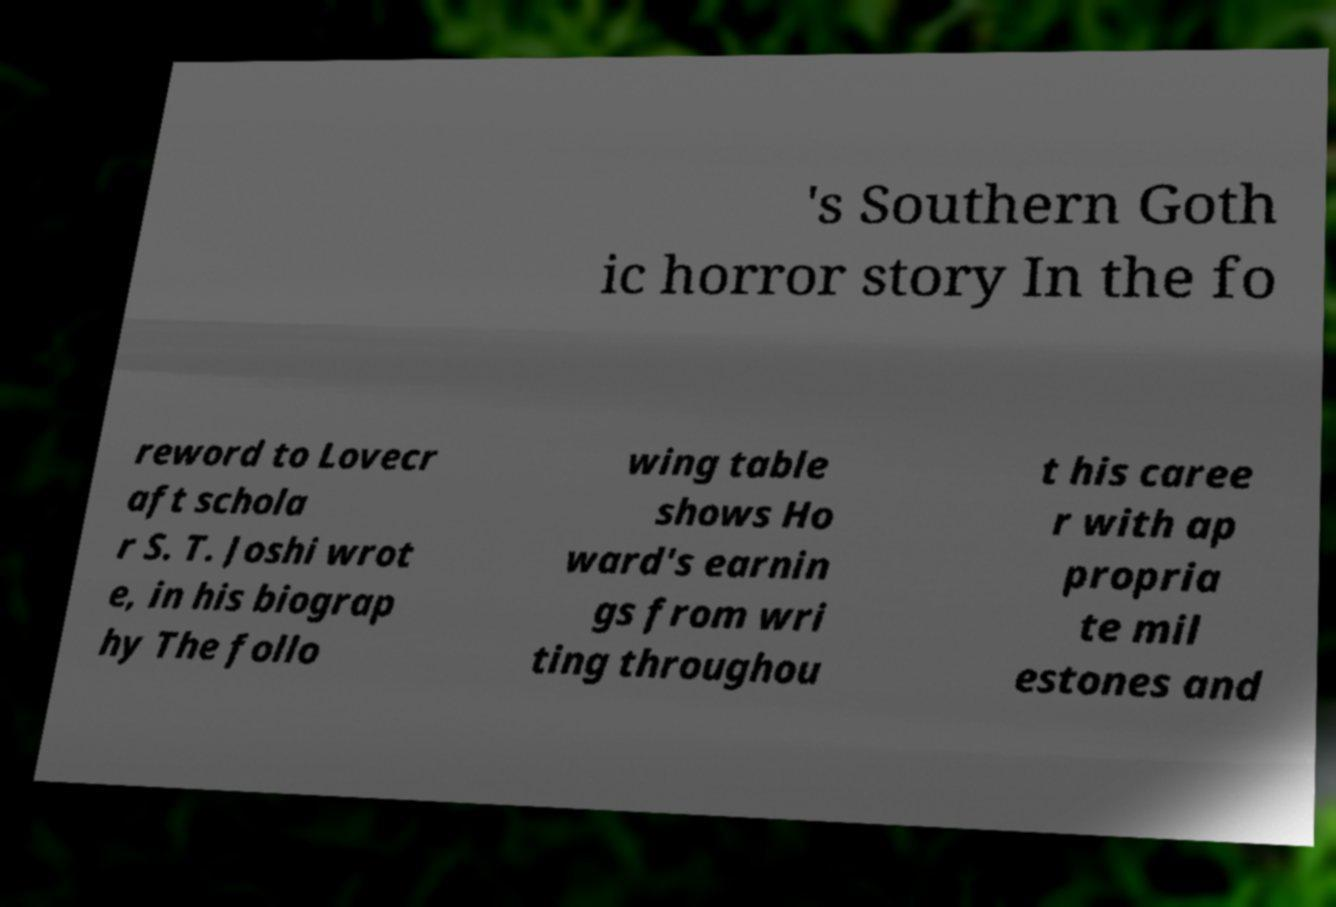Could you extract and type out the text from this image? 's Southern Goth ic horror story In the fo reword to Lovecr aft schola r S. T. Joshi wrot e, in his biograp hy The follo wing table shows Ho ward's earnin gs from wri ting throughou t his caree r with ap propria te mil estones and 